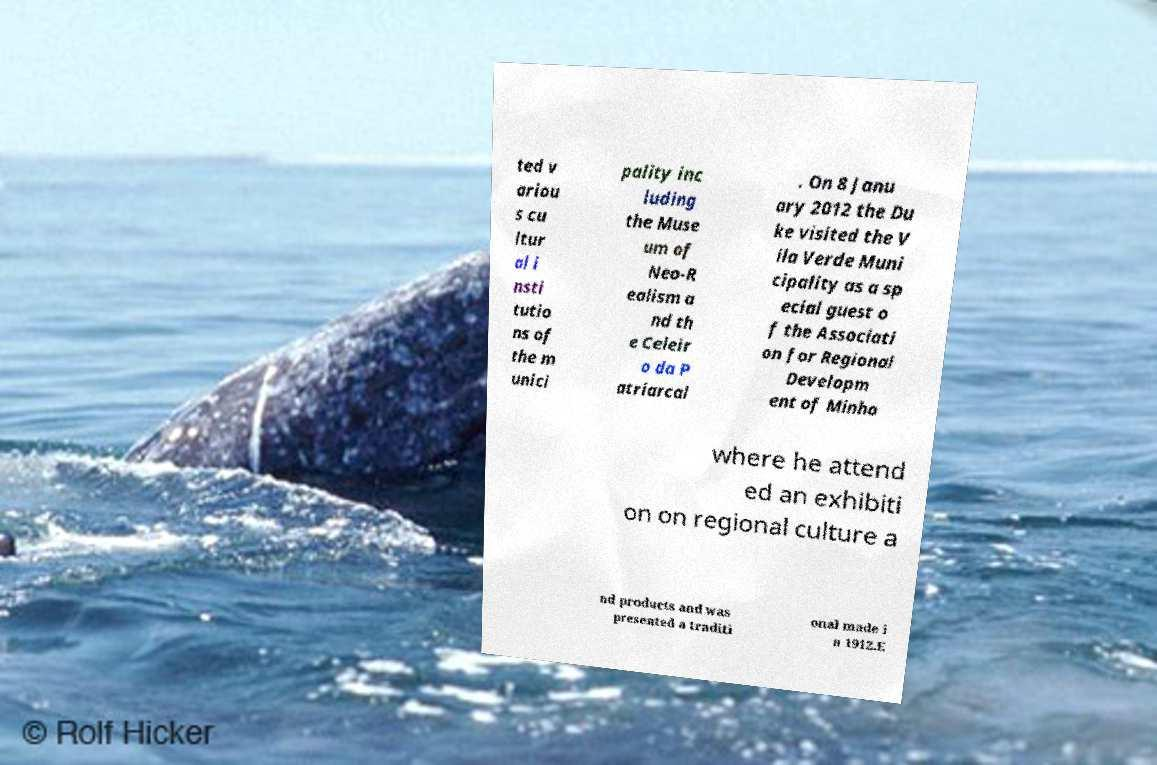What messages or text are displayed in this image? I need them in a readable, typed format. ted v ariou s cu ltur al i nsti tutio ns of the m unici pality inc luding the Muse um of Neo-R ealism a nd th e Celeir o da P atriarcal . On 8 Janu ary 2012 the Du ke visited the V ila Verde Muni cipality as a sp ecial guest o f the Associati on for Regional Developm ent of Minho where he attend ed an exhibiti on on regional culture a nd products and was presented a traditi onal made i n 1912.E 